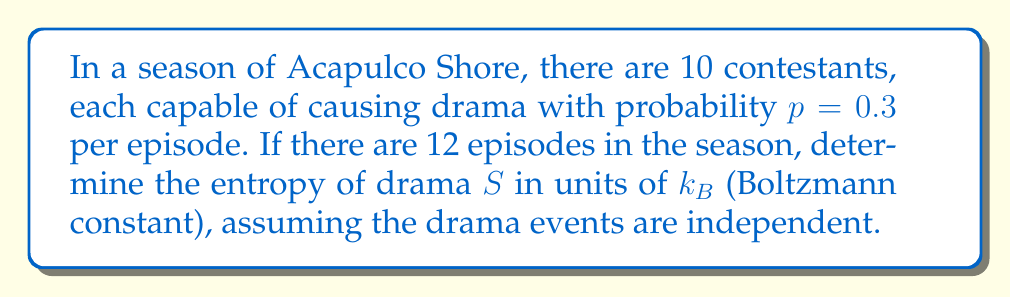Help me with this question. To solve this problem, we'll use concepts from statistical mechanics:

1) First, we need to calculate the number of microstates. Each contestant in each episode has two possible states: causing drama (1) or not causing drama (0).

2) The total number of microstates is:
   $$\Omega = 2^{10 \times 12} = 2^{120}$$

3) The probability of a specific microstate occurring is:
   $$P = p^k (1-p)^{(120-k)}$$
   where $k$ is the number of drama events.

4) The entropy is given by the Boltzmann formula:
   $$S = k_B \ln \Omega$$

5) Substituting the values:
   $$S = k_B \ln (2^{120}) = 120 k_B \ln 2$$

6) Using the property of logarithms:
   $$S = 120 k_B \times 0.693 = 83.16 k_B$$

Therefore, the entropy of drama in the Acapulco Shore season is approximately $83.16 k_B$.
Answer: $83.16 k_B$ 